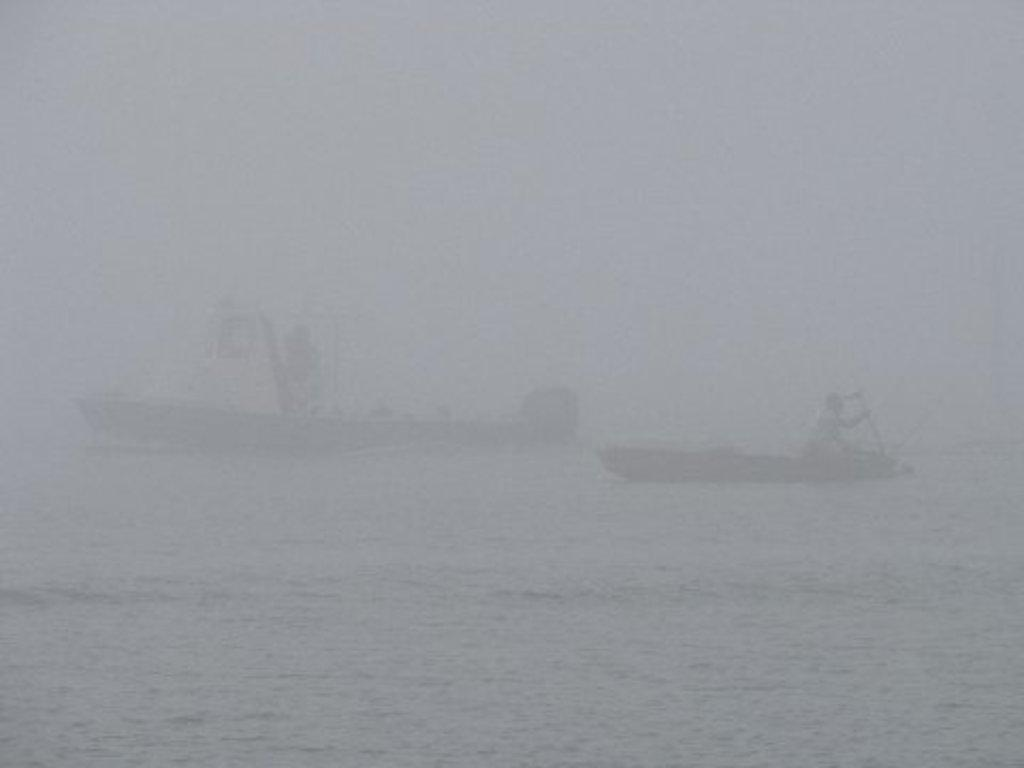How many boats can be seen in the image? There are two boats in the image. What are the boats doing in the image? The boats are sailing on the sea. What weather condition is present in the image? There is fog in the image, covering a large area. What type of destruction can be seen in the aftermath of the storm in the image? There is no storm or destruction present in the image; it only shows two boats sailing on the sea with fog. 